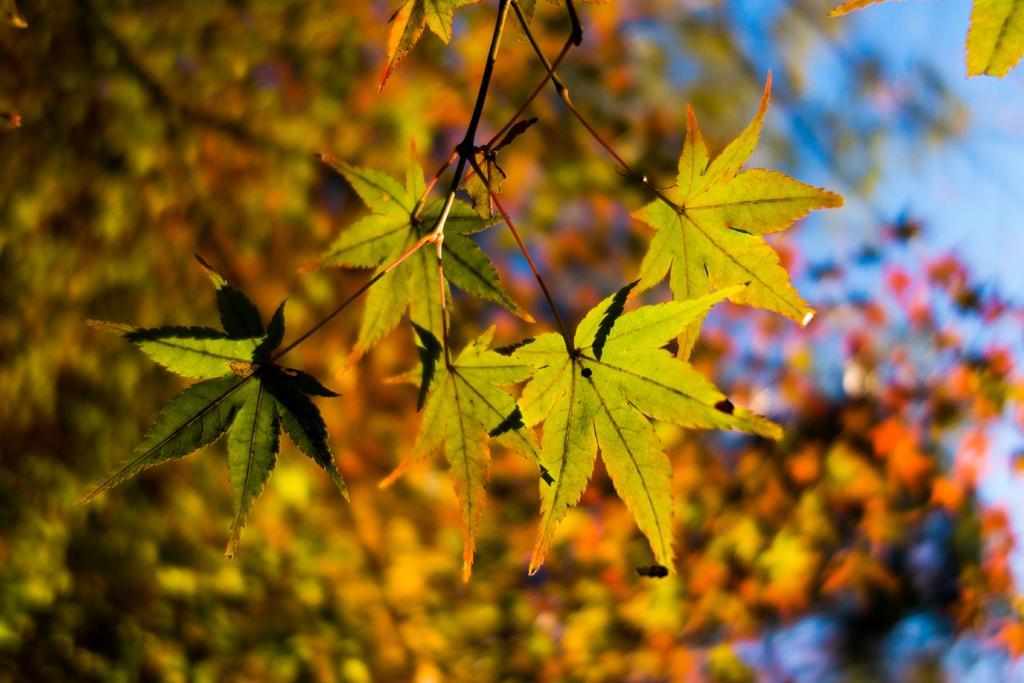Please provide a concise description of this image. In the image we can see the leaves and a blue sky, and the background is blurred. 